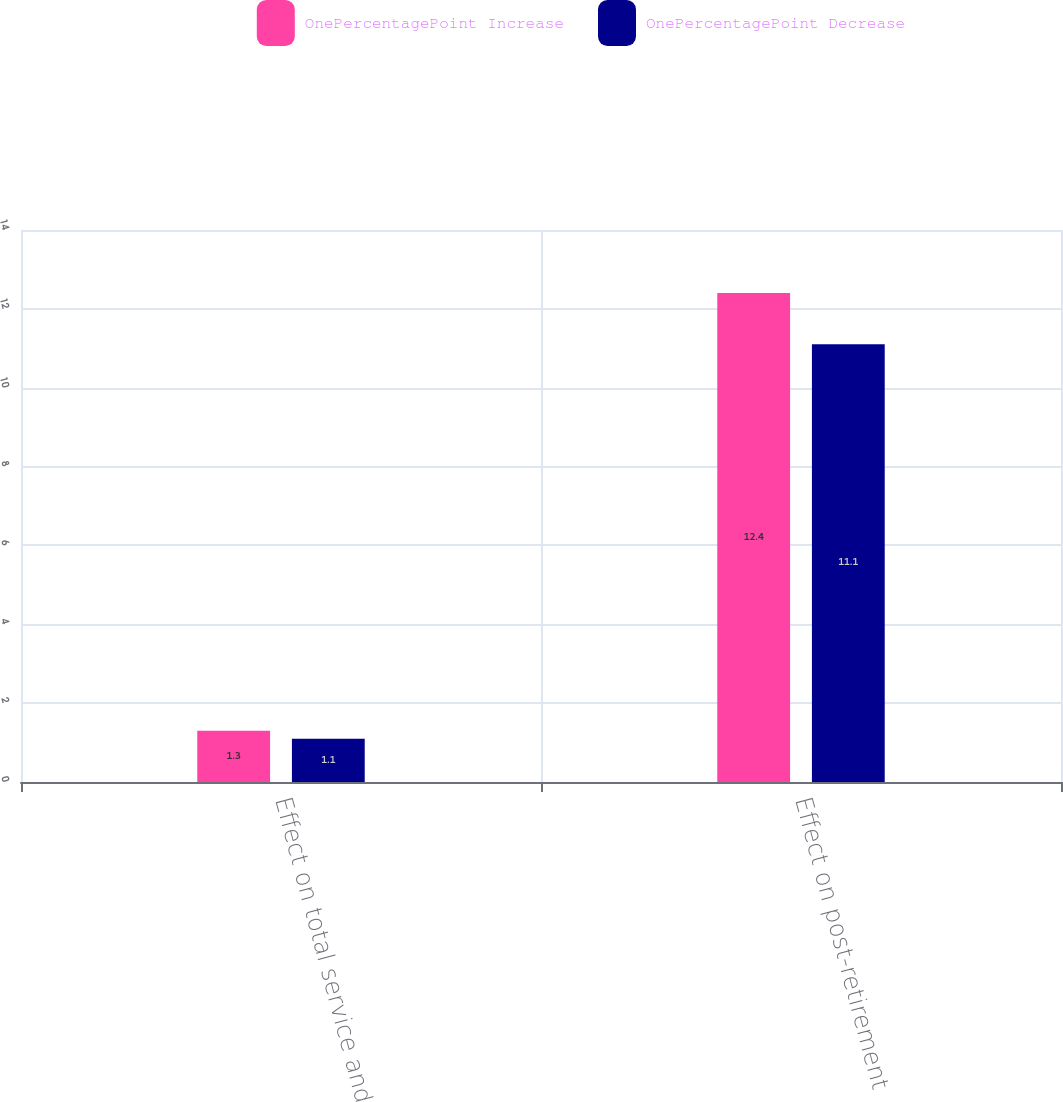<chart> <loc_0><loc_0><loc_500><loc_500><stacked_bar_chart><ecel><fcel>Effect on total service and<fcel>Effect on post-retirement<nl><fcel>OnePercentagePoint Increase<fcel>1.3<fcel>12.4<nl><fcel>OnePercentagePoint Decrease<fcel>1.1<fcel>11.1<nl></chart> 